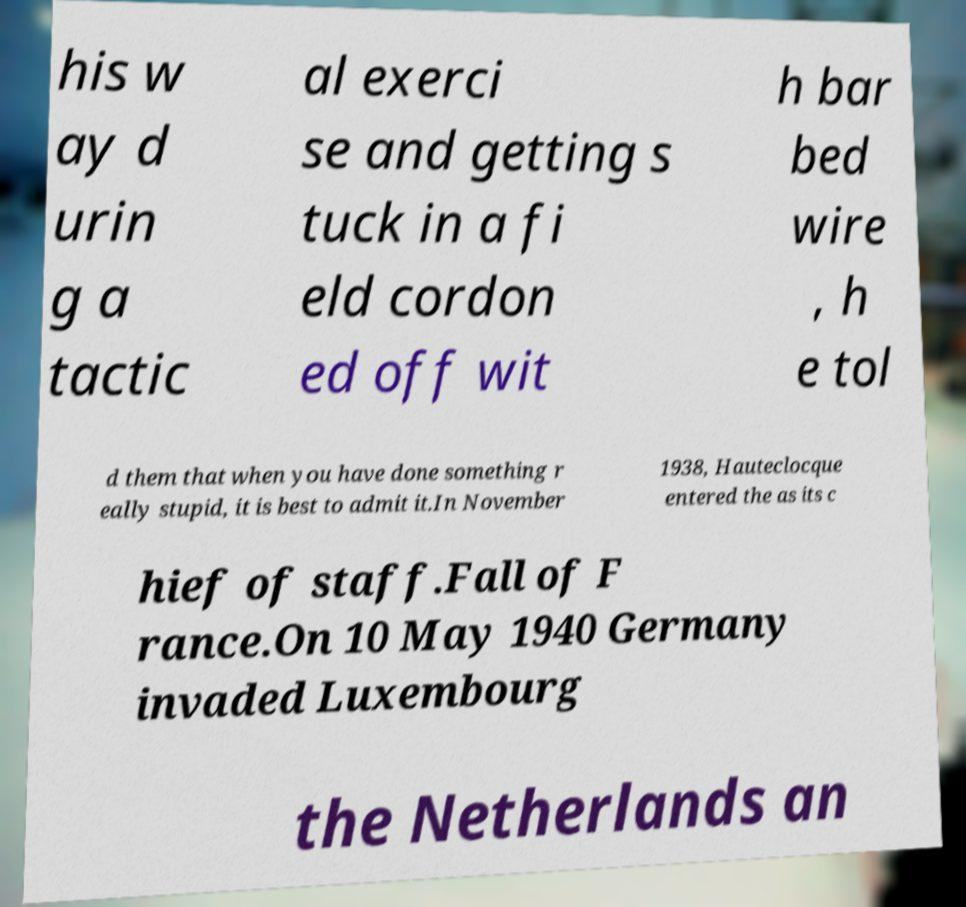Please read and relay the text visible in this image. What does it say? his w ay d urin g a tactic al exerci se and getting s tuck in a fi eld cordon ed off wit h bar bed wire , h e tol d them that when you have done something r eally stupid, it is best to admit it.In November 1938, Hauteclocque entered the as its c hief of staff.Fall of F rance.On 10 May 1940 Germany invaded Luxembourg the Netherlands an 